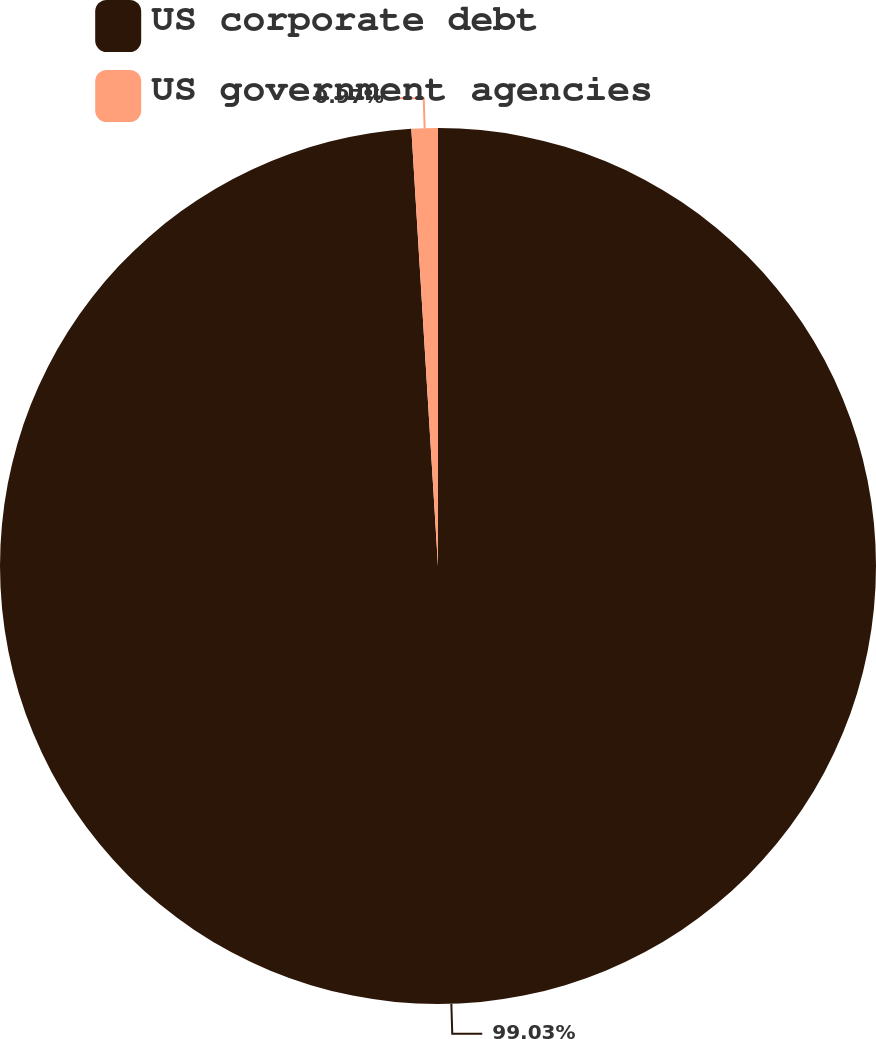Convert chart. <chart><loc_0><loc_0><loc_500><loc_500><pie_chart><fcel>US corporate debt<fcel>US government agencies<nl><fcel>99.03%<fcel>0.97%<nl></chart> 